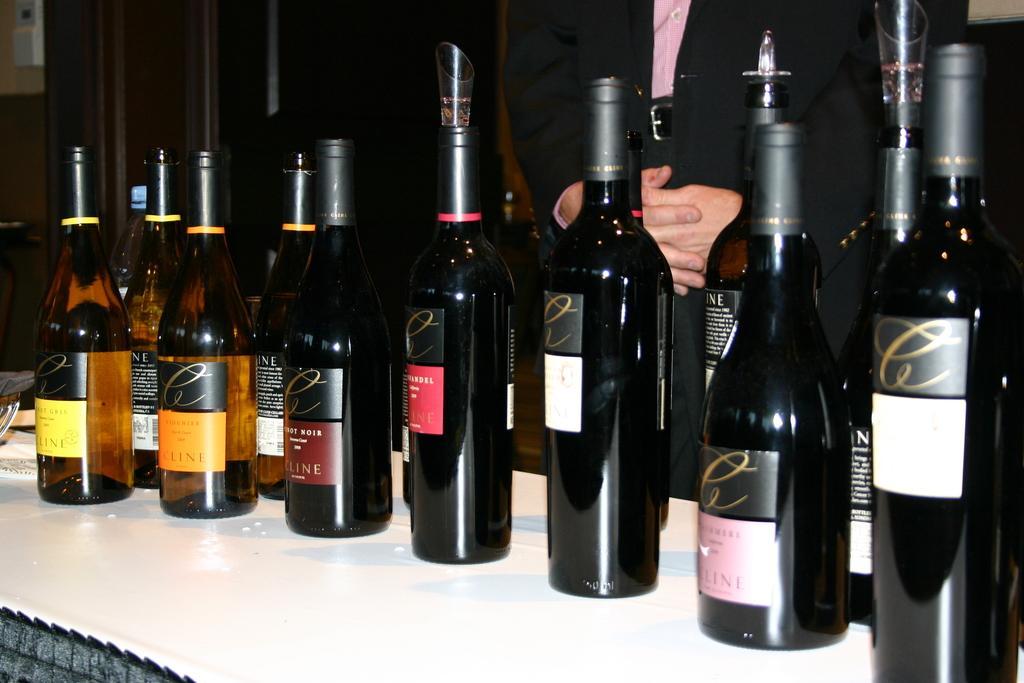How would you summarize this image in a sentence or two? In this image I see number of bottles and I see a person behind the bottles. 